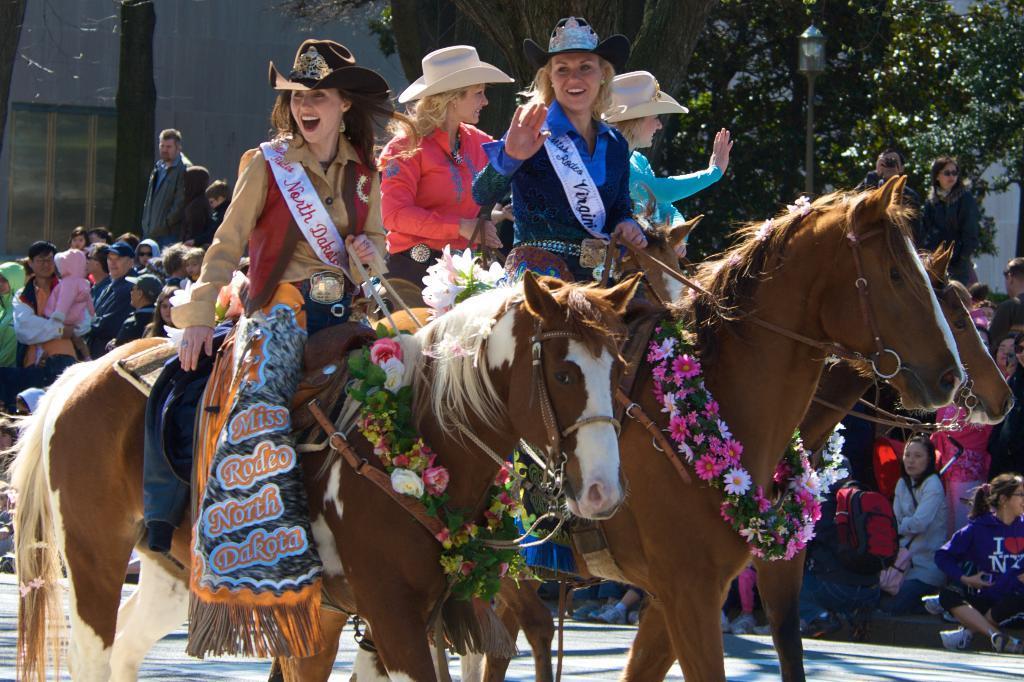Could you give a brief overview of what you see in this image? In this image there are people, horses, garland, trees, light pole, window, wall and objects. 